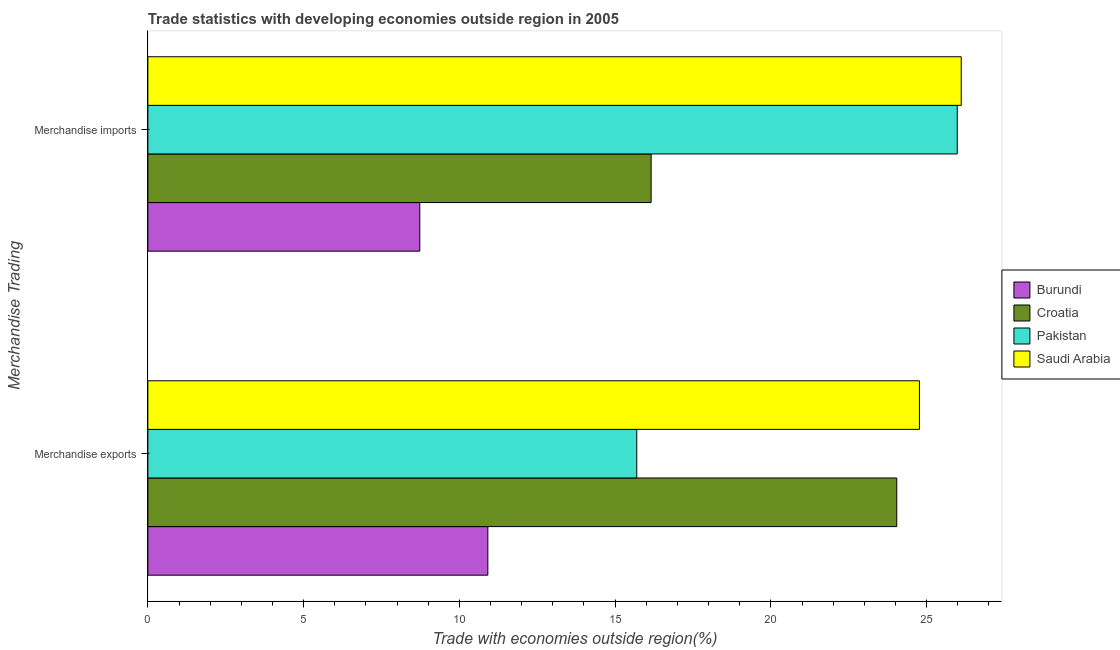How many groups of bars are there?
Offer a terse response. 2. Are the number of bars per tick equal to the number of legend labels?
Offer a very short reply. Yes. What is the merchandise imports in Pakistan?
Give a very brief answer. 25.98. Across all countries, what is the maximum merchandise imports?
Offer a terse response. 26.11. Across all countries, what is the minimum merchandise imports?
Make the answer very short. 8.73. In which country was the merchandise exports maximum?
Your answer should be compact. Saudi Arabia. In which country was the merchandise imports minimum?
Provide a short and direct response. Burundi. What is the total merchandise exports in the graph?
Provide a short and direct response. 75.42. What is the difference between the merchandise exports in Saudi Arabia and that in Croatia?
Your answer should be very brief. 0.73. What is the difference between the merchandise exports in Saudi Arabia and the merchandise imports in Burundi?
Your answer should be very brief. 16.04. What is the average merchandise imports per country?
Your answer should be very brief. 19.25. What is the difference between the merchandise exports and merchandise imports in Pakistan?
Make the answer very short. -10.29. In how many countries, is the merchandise imports greater than 8 %?
Give a very brief answer. 4. What is the ratio of the merchandise imports in Pakistan to that in Saudi Arabia?
Offer a terse response. 1. Is the merchandise imports in Croatia less than that in Pakistan?
Keep it short and to the point. Yes. In how many countries, is the merchandise exports greater than the average merchandise exports taken over all countries?
Your response must be concise. 2. What does the 2nd bar from the top in Merchandise exports represents?
Offer a very short reply. Pakistan. What does the 2nd bar from the bottom in Merchandise imports represents?
Offer a terse response. Croatia. How many bars are there?
Your response must be concise. 8. Are all the bars in the graph horizontal?
Offer a very short reply. Yes. How many countries are there in the graph?
Offer a terse response. 4. What is the difference between two consecutive major ticks on the X-axis?
Provide a short and direct response. 5. Does the graph contain any zero values?
Your answer should be compact. No. What is the title of the graph?
Make the answer very short. Trade statistics with developing economies outside region in 2005. What is the label or title of the X-axis?
Offer a very short reply. Trade with economies outside region(%). What is the label or title of the Y-axis?
Keep it short and to the point. Merchandise Trading. What is the Trade with economies outside region(%) in Burundi in Merchandise exports?
Offer a very short reply. 10.91. What is the Trade with economies outside region(%) in Croatia in Merchandise exports?
Give a very brief answer. 24.04. What is the Trade with economies outside region(%) of Pakistan in Merchandise exports?
Give a very brief answer. 15.69. What is the Trade with economies outside region(%) in Saudi Arabia in Merchandise exports?
Your response must be concise. 24.77. What is the Trade with economies outside region(%) of Burundi in Merchandise imports?
Give a very brief answer. 8.73. What is the Trade with economies outside region(%) in Croatia in Merchandise imports?
Provide a succinct answer. 16.16. What is the Trade with economies outside region(%) of Pakistan in Merchandise imports?
Make the answer very short. 25.98. What is the Trade with economies outside region(%) of Saudi Arabia in Merchandise imports?
Provide a short and direct response. 26.11. Across all Merchandise Trading, what is the maximum Trade with economies outside region(%) of Burundi?
Keep it short and to the point. 10.91. Across all Merchandise Trading, what is the maximum Trade with economies outside region(%) in Croatia?
Make the answer very short. 24.04. Across all Merchandise Trading, what is the maximum Trade with economies outside region(%) in Pakistan?
Ensure brevity in your answer.  25.98. Across all Merchandise Trading, what is the maximum Trade with economies outside region(%) of Saudi Arabia?
Offer a very short reply. 26.11. Across all Merchandise Trading, what is the minimum Trade with economies outside region(%) of Burundi?
Your answer should be compact. 8.73. Across all Merchandise Trading, what is the minimum Trade with economies outside region(%) in Croatia?
Make the answer very short. 16.16. Across all Merchandise Trading, what is the minimum Trade with economies outside region(%) in Pakistan?
Offer a very short reply. 15.69. Across all Merchandise Trading, what is the minimum Trade with economies outside region(%) in Saudi Arabia?
Keep it short and to the point. 24.77. What is the total Trade with economies outside region(%) in Burundi in the graph?
Your response must be concise. 19.64. What is the total Trade with economies outside region(%) of Croatia in the graph?
Ensure brevity in your answer.  40.2. What is the total Trade with economies outside region(%) of Pakistan in the graph?
Keep it short and to the point. 41.68. What is the total Trade with economies outside region(%) in Saudi Arabia in the graph?
Provide a short and direct response. 50.88. What is the difference between the Trade with economies outside region(%) of Burundi in Merchandise exports and that in Merchandise imports?
Provide a succinct answer. 2.18. What is the difference between the Trade with economies outside region(%) in Croatia in Merchandise exports and that in Merchandise imports?
Offer a terse response. 7.89. What is the difference between the Trade with economies outside region(%) of Pakistan in Merchandise exports and that in Merchandise imports?
Provide a short and direct response. -10.29. What is the difference between the Trade with economies outside region(%) in Saudi Arabia in Merchandise exports and that in Merchandise imports?
Keep it short and to the point. -1.34. What is the difference between the Trade with economies outside region(%) in Burundi in Merchandise exports and the Trade with economies outside region(%) in Croatia in Merchandise imports?
Ensure brevity in your answer.  -5.24. What is the difference between the Trade with economies outside region(%) of Burundi in Merchandise exports and the Trade with economies outside region(%) of Pakistan in Merchandise imports?
Ensure brevity in your answer.  -15.07. What is the difference between the Trade with economies outside region(%) in Burundi in Merchandise exports and the Trade with economies outside region(%) in Saudi Arabia in Merchandise imports?
Your answer should be very brief. -15.2. What is the difference between the Trade with economies outside region(%) of Croatia in Merchandise exports and the Trade with economies outside region(%) of Pakistan in Merchandise imports?
Make the answer very short. -1.94. What is the difference between the Trade with economies outside region(%) of Croatia in Merchandise exports and the Trade with economies outside region(%) of Saudi Arabia in Merchandise imports?
Keep it short and to the point. -2.07. What is the difference between the Trade with economies outside region(%) in Pakistan in Merchandise exports and the Trade with economies outside region(%) in Saudi Arabia in Merchandise imports?
Your answer should be very brief. -10.42. What is the average Trade with economies outside region(%) in Burundi per Merchandise Trading?
Keep it short and to the point. 9.82. What is the average Trade with economies outside region(%) of Croatia per Merchandise Trading?
Ensure brevity in your answer.  20.1. What is the average Trade with economies outside region(%) of Pakistan per Merchandise Trading?
Offer a terse response. 20.84. What is the average Trade with economies outside region(%) in Saudi Arabia per Merchandise Trading?
Provide a short and direct response. 25.44. What is the difference between the Trade with economies outside region(%) of Burundi and Trade with economies outside region(%) of Croatia in Merchandise exports?
Provide a short and direct response. -13.13. What is the difference between the Trade with economies outside region(%) of Burundi and Trade with economies outside region(%) of Pakistan in Merchandise exports?
Your answer should be compact. -4.78. What is the difference between the Trade with economies outside region(%) in Burundi and Trade with economies outside region(%) in Saudi Arabia in Merchandise exports?
Your answer should be compact. -13.86. What is the difference between the Trade with economies outside region(%) in Croatia and Trade with economies outside region(%) in Pakistan in Merchandise exports?
Your response must be concise. 8.35. What is the difference between the Trade with economies outside region(%) of Croatia and Trade with economies outside region(%) of Saudi Arabia in Merchandise exports?
Ensure brevity in your answer.  -0.73. What is the difference between the Trade with economies outside region(%) in Pakistan and Trade with economies outside region(%) in Saudi Arabia in Merchandise exports?
Offer a terse response. -9.07. What is the difference between the Trade with economies outside region(%) in Burundi and Trade with economies outside region(%) in Croatia in Merchandise imports?
Offer a terse response. -7.43. What is the difference between the Trade with economies outside region(%) in Burundi and Trade with economies outside region(%) in Pakistan in Merchandise imports?
Provide a succinct answer. -17.25. What is the difference between the Trade with economies outside region(%) of Burundi and Trade with economies outside region(%) of Saudi Arabia in Merchandise imports?
Make the answer very short. -17.38. What is the difference between the Trade with economies outside region(%) of Croatia and Trade with economies outside region(%) of Pakistan in Merchandise imports?
Your answer should be compact. -9.83. What is the difference between the Trade with economies outside region(%) in Croatia and Trade with economies outside region(%) in Saudi Arabia in Merchandise imports?
Ensure brevity in your answer.  -9.96. What is the difference between the Trade with economies outside region(%) in Pakistan and Trade with economies outside region(%) in Saudi Arabia in Merchandise imports?
Give a very brief answer. -0.13. What is the ratio of the Trade with economies outside region(%) of Burundi in Merchandise exports to that in Merchandise imports?
Provide a succinct answer. 1.25. What is the ratio of the Trade with economies outside region(%) of Croatia in Merchandise exports to that in Merchandise imports?
Your answer should be compact. 1.49. What is the ratio of the Trade with economies outside region(%) of Pakistan in Merchandise exports to that in Merchandise imports?
Provide a short and direct response. 0.6. What is the ratio of the Trade with economies outside region(%) in Saudi Arabia in Merchandise exports to that in Merchandise imports?
Make the answer very short. 0.95. What is the difference between the highest and the second highest Trade with economies outside region(%) in Burundi?
Make the answer very short. 2.18. What is the difference between the highest and the second highest Trade with economies outside region(%) of Croatia?
Keep it short and to the point. 7.89. What is the difference between the highest and the second highest Trade with economies outside region(%) of Pakistan?
Your answer should be compact. 10.29. What is the difference between the highest and the second highest Trade with economies outside region(%) in Saudi Arabia?
Ensure brevity in your answer.  1.34. What is the difference between the highest and the lowest Trade with economies outside region(%) in Burundi?
Provide a short and direct response. 2.18. What is the difference between the highest and the lowest Trade with economies outside region(%) in Croatia?
Provide a short and direct response. 7.89. What is the difference between the highest and the lowest Trade with economies outside region(%) in Pakistan?
Offer a very short reply. 10.29. What is the difference between the highest and the lowest Trade with economies outside region(%) in Saudi Arabia?
Give a very brief answer. 1.34. 